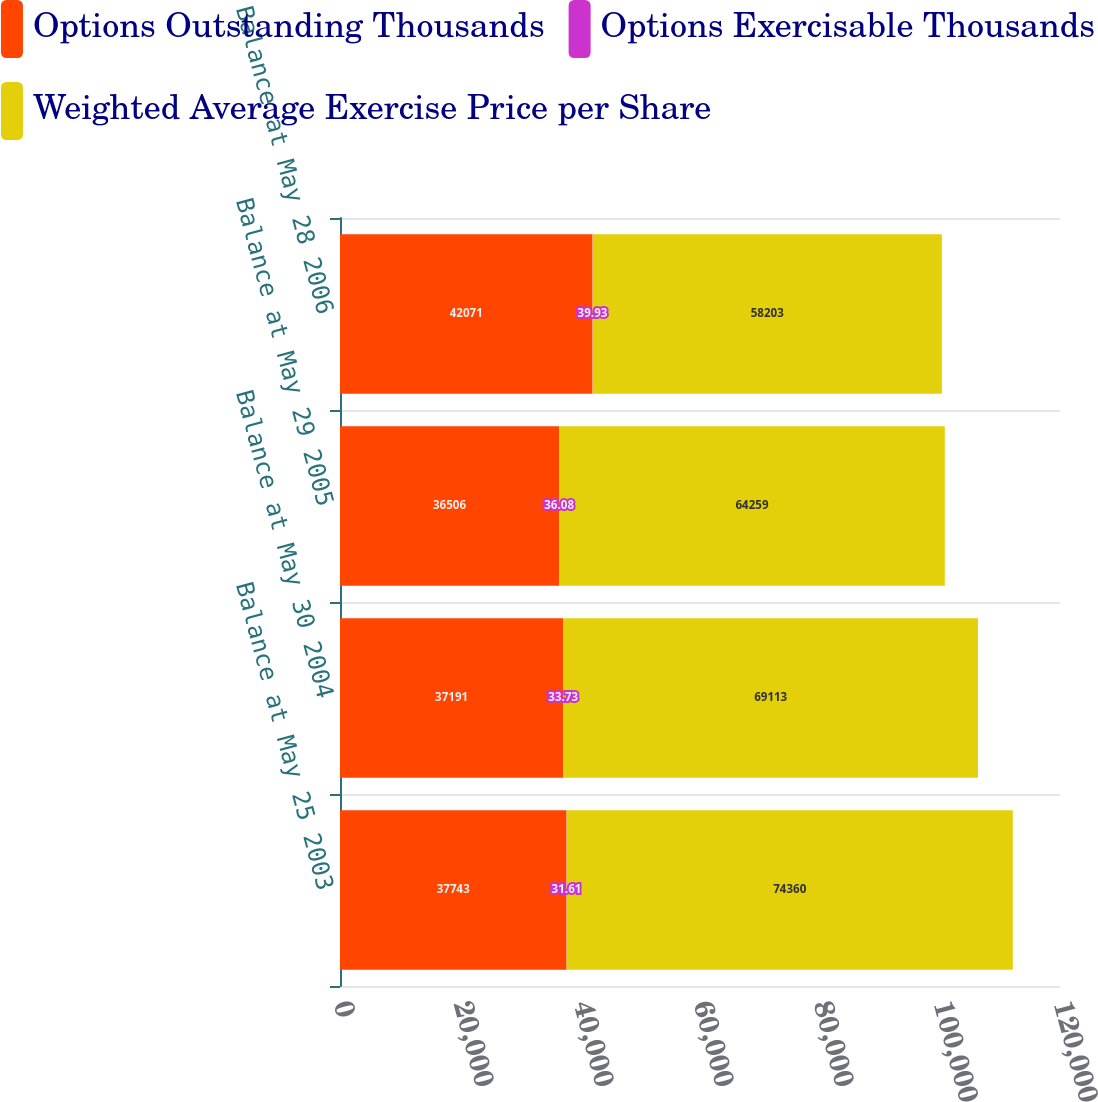<chart> <loc_0><loc_0><loc_500><loc_500><stacked_bar_chart><ecel><fcel>Balance at May 25 2003<fcel>Balance at May 30 2004<fcel>Balance at May 29 2005<fcel>Balance at May 28 2006<nl><fcel>Options Outstanding Thousands<fcel>37743<fcel>37191<fcel>36506<fcel>42071<nl><fcel>Options Exercisable Thousands<fcel>31.61<fcel>33.73<fcel>36.08<fcel>39.93<nl><fcel>Weighted Average Exercise Price per Share<fcel>74360<fcel>69113<fcel>64259<fcel>58203<nl></chart> 